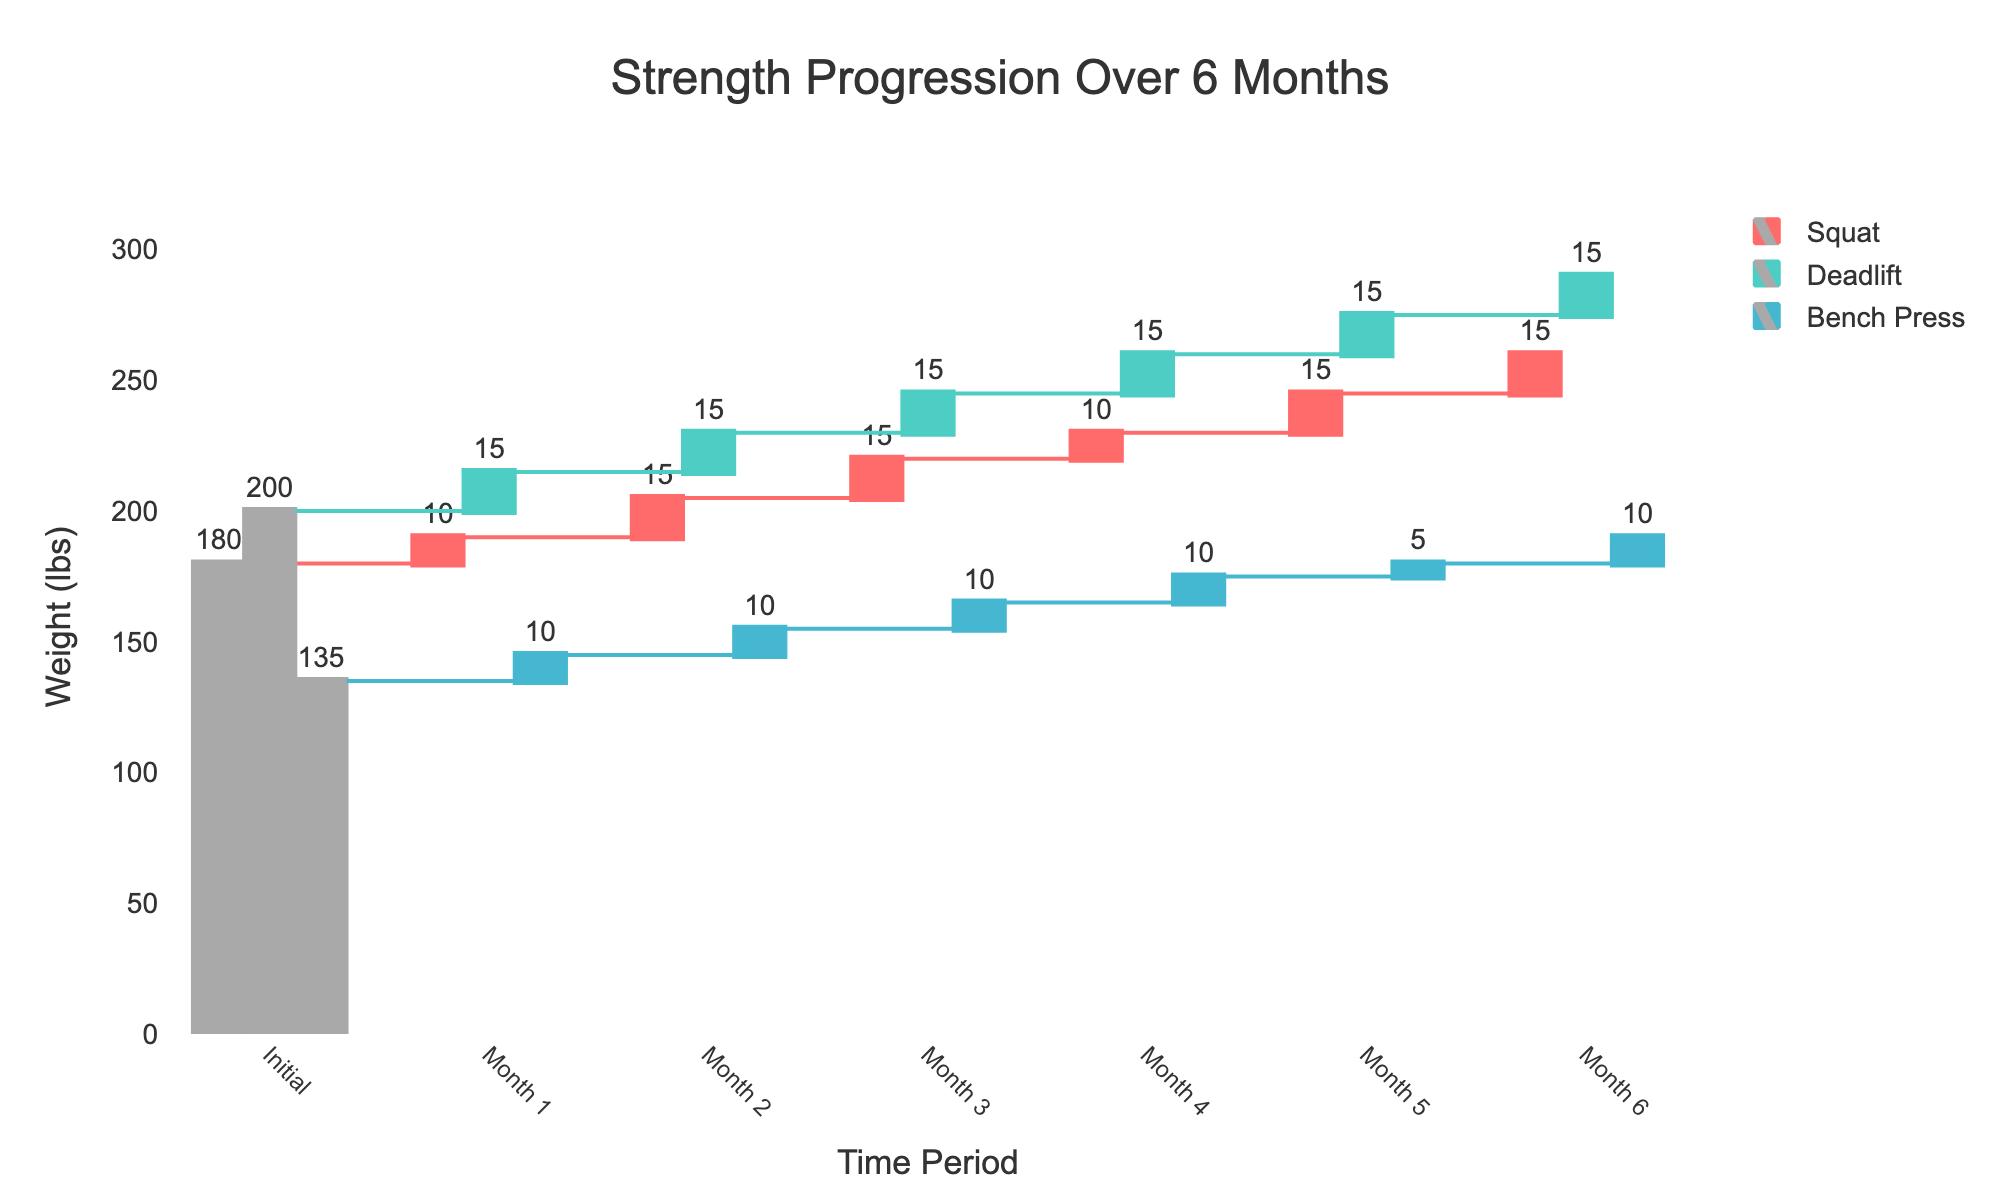what does the title of the chart indicate? The title of the chart is "Strength Progression Over 6 Months." It indicates that the chart visualizes the changes in strength in major lifts (squat, deadlift, bench press) over a six-month period.
Answer: Strength Progression Over 6 Months What are the three lifts shown in the figure? The three lifts shown in the figure are the squat, deadlift, and bench press.
Answer: Squat, Deadlift, Bench Press What period does the chart cover? The chart covers a period of six months, showing progression from the initial values up to month 6.
Answer: Six months Which lift shows the highest initial strength value? By observing the initial values displayed in the chart, deadlift has the highest initial strength value.
Answer: Deadlift How much did the squat increase from Month 2 to Month 3? The squat increased from 205 lbs in Month 2 to 220 lbs in Month 3. The difference is \( 220 - 205 = 15 \) lbs.
Answer: 15 lbs What is the total increase in strength for the bench press over six months? The bench press increased from 135 lbs initially to 190 lbs in Month 6. The total increase is \( 190 - 135 = 55 \) lbs.
Answer: 55 lbs Which lift had the largest gain between the initial point and month 1? The initial to month 1 gains are 10 lbs for squat (190 - 180), 15 lbs for deadlift (215 - 200), and 10 lbs for bench press (145 - 135). The deadlift had the largest gain of 15 lbs.
Answer: Deadlift How does the increase in deadlift strength from Month 3 to Month 4 compare to the increase in squat strength in the same period? From Month 3 to Month 4, deadlift increased from 245 lbs to 260 lbs, which is a 15 lbs gain. Squat increased from 220 lbs to 230 lbs, which is a 10 lbs gain. Thus, the deadlift had a greater increase.
Answer: Deadlift has a greater increase What is the average monthly increase in squat strength? The squat strength increases are 10, 15, 15, 10, 15, and 15 lbs across six months. The average monthly increase is the sum of these increases divided by 6: \( \frac{10 + 15 + 15 + 10 + 15 + 15}{6} = 13.33 \) lbs.
Answer: 13.33 lbs Which lift shows the smallest relative gain between any consecutive months? By examining the values, the smallest relative gain between any consecutive months is observed in the bench press from Month 5 to Month 6, increasing only from 180 lbs to 190 lbs, a 10 lbs gain.
Answer: Bench Press from Month 5 to Month 6 